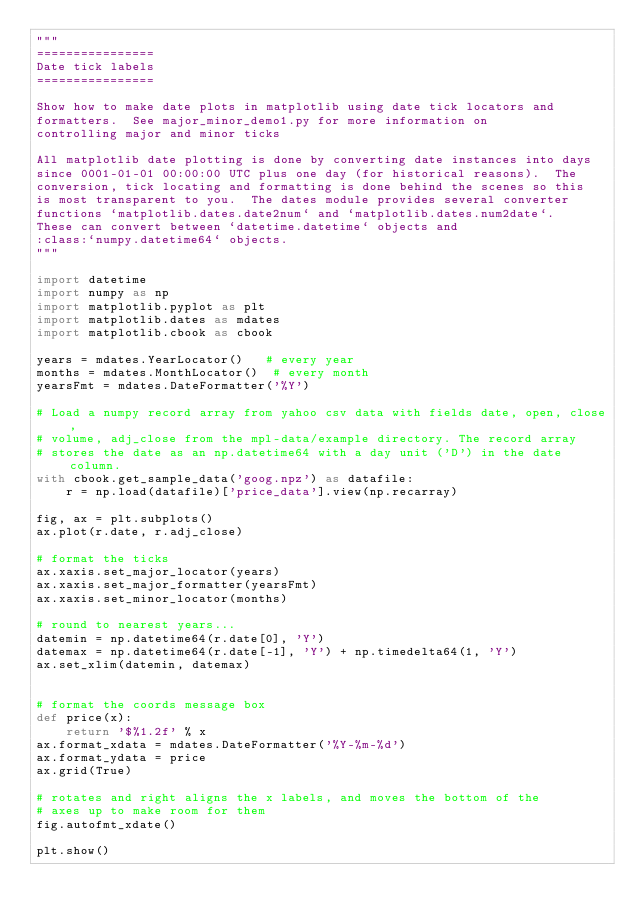Convert code to text. <code><loc_0><loc_0><loc_500><loc_500><_Python_>"""
================
Date tick labels
================

Show how to make date plots in matplotlib using date tick locators and
formatters.  See major_minor_demo1.py for more information on
controlling major and minor ticks

All matplotlib date plotting is done by converting date instances into days
since 0001-01-01 00:00:00 UTC plus one day (for historical reasons).  The
conversion, tick locating and formatting is done behind the scenes so this
is most transparent to you.  The dates module provides several converter
functions `matplotlib.dates.date2num` and `matplotlib.dates.num2date`.
These can convert between `datetime.datetime` objects and
:class:`numpy.datetime64` objects.
"""

import datetime
import numpy as np
import matplotlib.pyplot as plt
import matplotlib.dates as mdates
import matplotlib.cbook as cbook

years = mdates.YearLocator()   # every year
months = mdates.MonthLocator()  # every month
yearsFmt = mdates.DateFormatter('%Y')

# Load a numpy record array from yahoo csv data with fields date, open, close,
# volume, adj_close from the mpl-data/example directory. The record array
# stores the date as an np.datetime64 with a day unit ('D') in the date column.
with cbook.get_sample_data('goog.npz') as datafile:
    r = np.load(datafile)['price_data'].view(np.recarray)

fig, ax = plt.subplots()
ax.plot(r.date, r.adj_close)

# format the ticks
ax.xaxis.set_major_locator(years)
ax.xaxis.set_major_formatter(yearsFmt)
ax.xaxis.set_minor_locator(months)

# round to nearest years...
datemin = np.datetime64(r.date[0], 'Y')
datemax = np.datetime64(r.date[-1], 'Y') + np.timedelta64(1, 'Y')
ax.set_xlim(datemin, datemax)


# format the coords message box
def price(x):
    return '$%1.2f' % x
ax.format_xdata = mdates.DateFormatter('%Y-%m-%d')
ax.format_ydata = price
ax.grid(True)

# rotates and right aligns the x labels, and moves the bottom of the
# axes up to make room for them
fig.autofmt_xdate()

plt.show()
</code> 